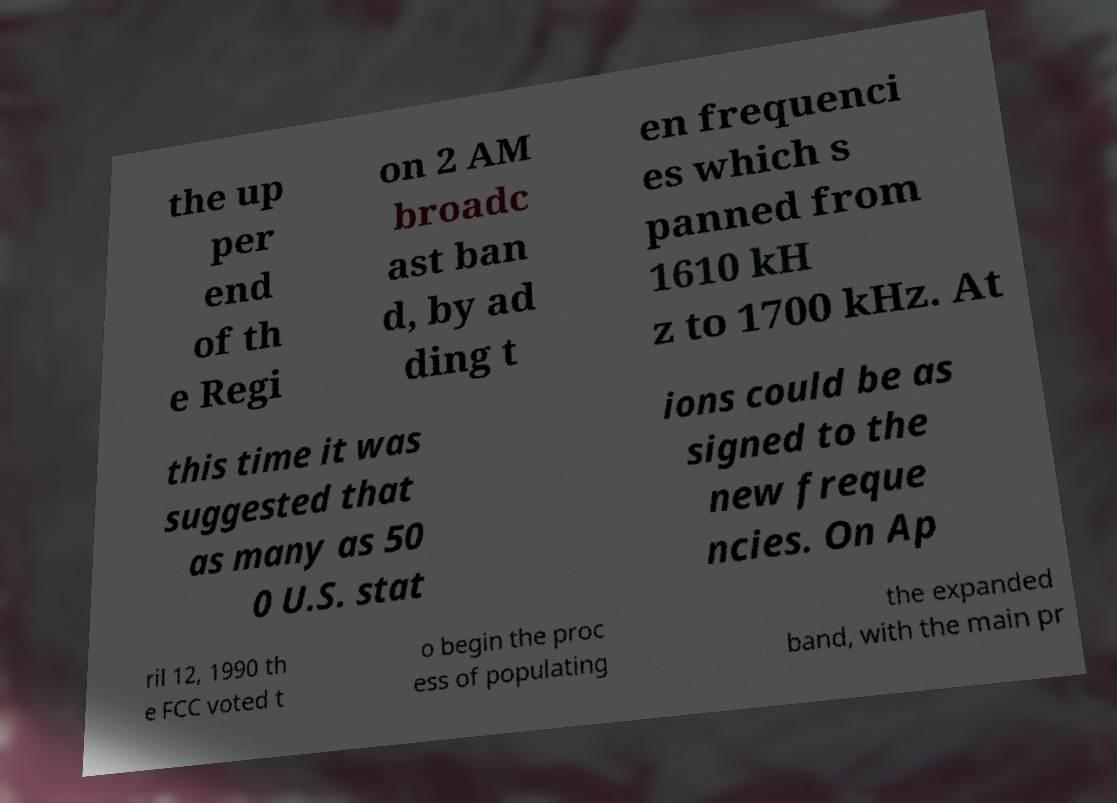Please read and relay the text visible in this image. What does it say? the up per end of th e Regi on 2 AM broadc ast ban d, by ad ding t en frequenci es which s panned from 1610 kH z to 1700 kHz. At this time it was suggested that as many as 50 0 U.S. stat ions could be as signed to the new freque ncies. On Ap ril 12, 1990 th e FCC voted t o begin the proc ess of populating the expanded band, with the main pr 